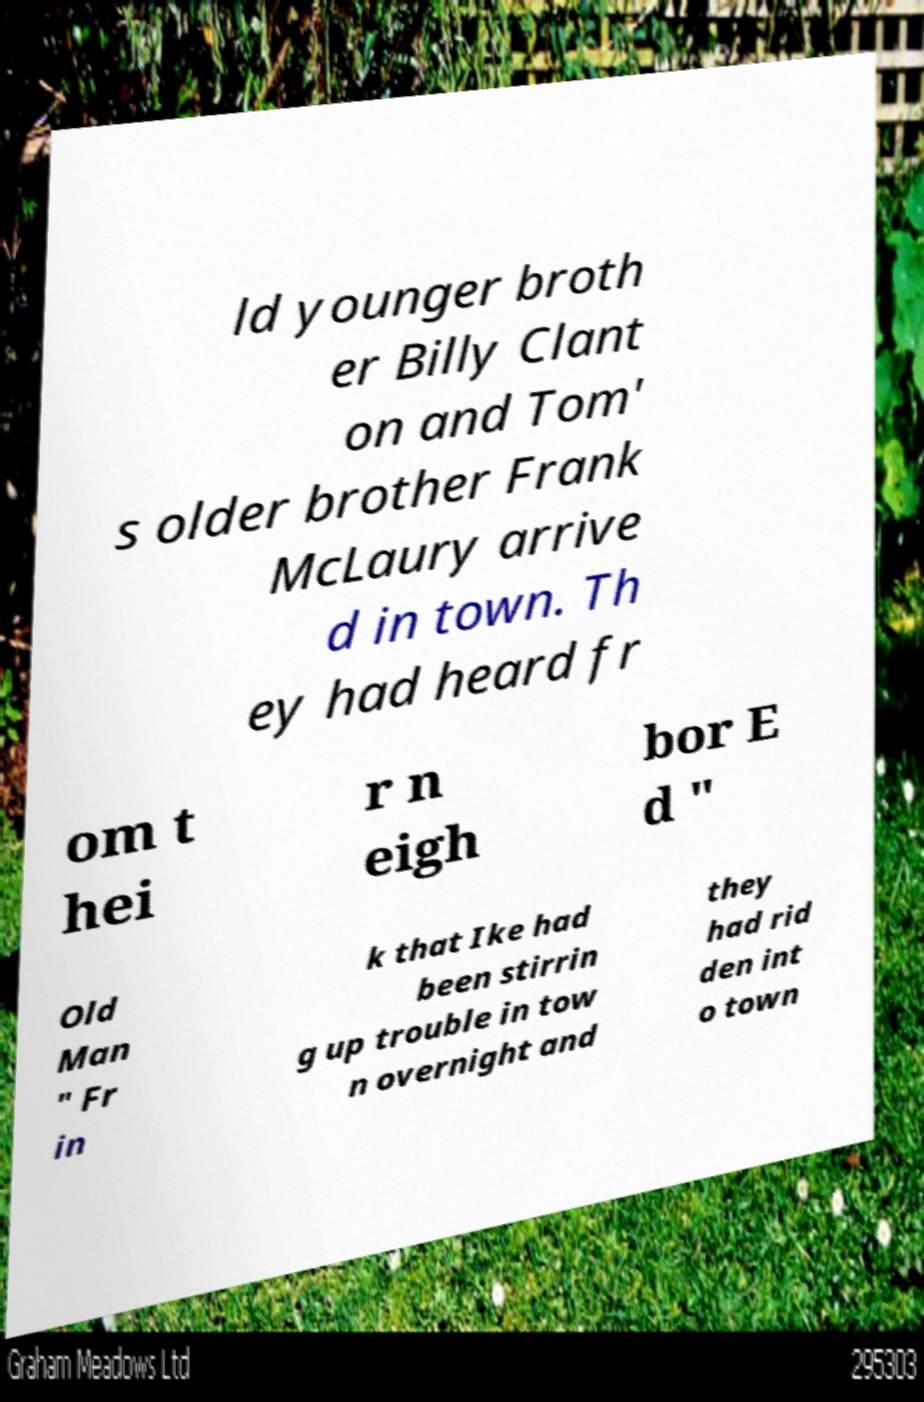Can you read and provide the text displayed in the image?This photo seems to have some interesting text. Can you extract and type it out for me? ld younger broth er Billy Clant on and Tom' s older brother Frank McLaury arrive d in town. Th ey had heard fr om t hei r n eigh bor E d " Old Man " Fr in k that Ike had been stirrin g up trouble in tow n overnight and they had rid den int o town 